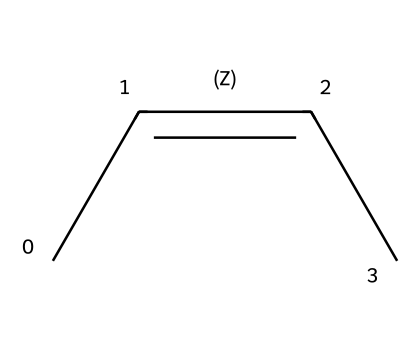What is the name of this chemical compound? The SMILES representation corresponds to a compound with a specific arrangement of carbon atoms and double bonds, which can be recognized as cis-2-butene.
Answer: cis-2-butene How many carbon atoms are in the structure? By analyzing the SMILES structure, we can see that there are four carbon atoms (C) depicted. Each carbon is connected as specified, confirming the total count.
Answer: four What is the degree of unsaturation in this compound? The degree of unsaturation indicates the number of double bonds or rings. For cis-2-butene, there is one double bond between two carbon atoms, resulting in a degree of unsaturation of one.
Answer: one How many hydrogen atoms are bonded to the double-bonded carbon atoms? In the cis-2-butene structure, each of the double-bonded carbon atoms has one hydrogen atom bonded to it, totaling two hydrogen atoms for both carbons.
Answer: two What specific feature of cis-2-butene distinguishes it from its trans isomer? The cis configuration of the double bond means that the substituents (hydrogens) are on the same side, unlike the trans isomer where they are on opposite sides, thus distinguishing it visually and structurally.
Answer: same side Explain how the geometric isomerism affects its physical properties. Geometric isomerism can lead to different physical properties such as boiling points, melting points, and solubilities. In the case of cis-2-butene, the spatial arrangement affects its polarity and thus its interactions with other substances, compared to the trans version.
Answer: affects polarity 